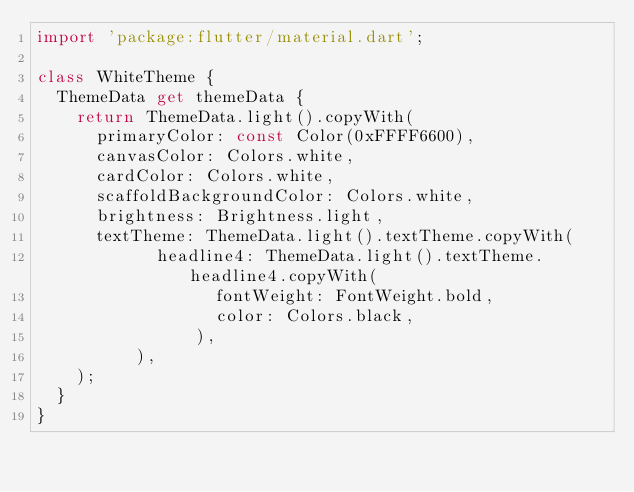<code> <loc_0><loc_0><loc_500><loc_500><_Dart_>import 'package:flutter/material.dart';

class WhiteTheme {
  ThemeData get themeData {
    return ThemeData.light().copyWith(
      primaryColor: const Color(0xFFFF6600),
      canvasColor: Colors.white,
      cardColor: Colors.white,
      scaffoldBackgroundColor: Colors.white,
      brightness: Brightness.light,
      textTheme: ThemeData.light().textTheme.copyWith(
            headline4: ThemeData.light().textTheme.headline4.copyWith(
                  fontWeight: FontWeight.bold,
                  color: Colors.black,
                ),
          ),
    );
  }
}
</code> 